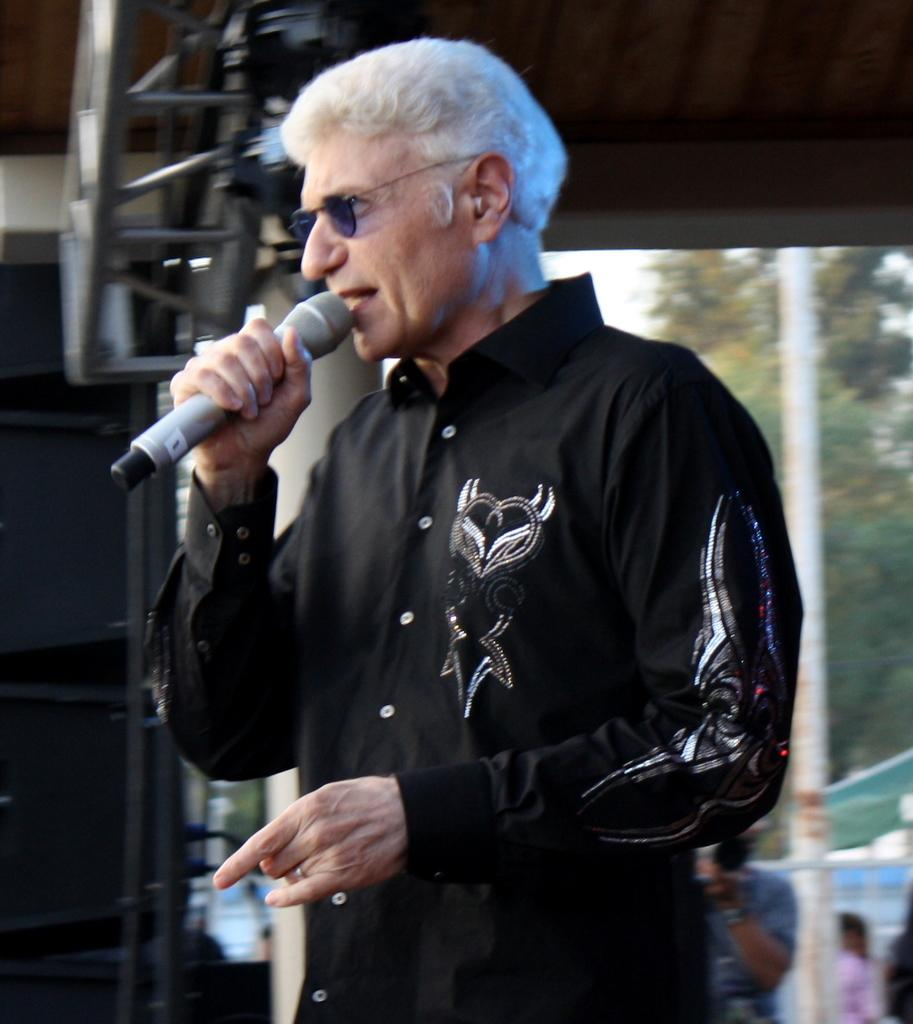Who is present in the image? There is a man in the image. What is the man holding in his hand? The man is holding a mic in his hand. What can be seen in the background of the image? There is a tree and a pole in the background of the image. What type of bag is the man carrying in the image? There is no bag present in the image; the man is holding a mic in his hand. What drink is the man consuming in the image? There is no drink present in the image; the man is holding a mic in his hand. 